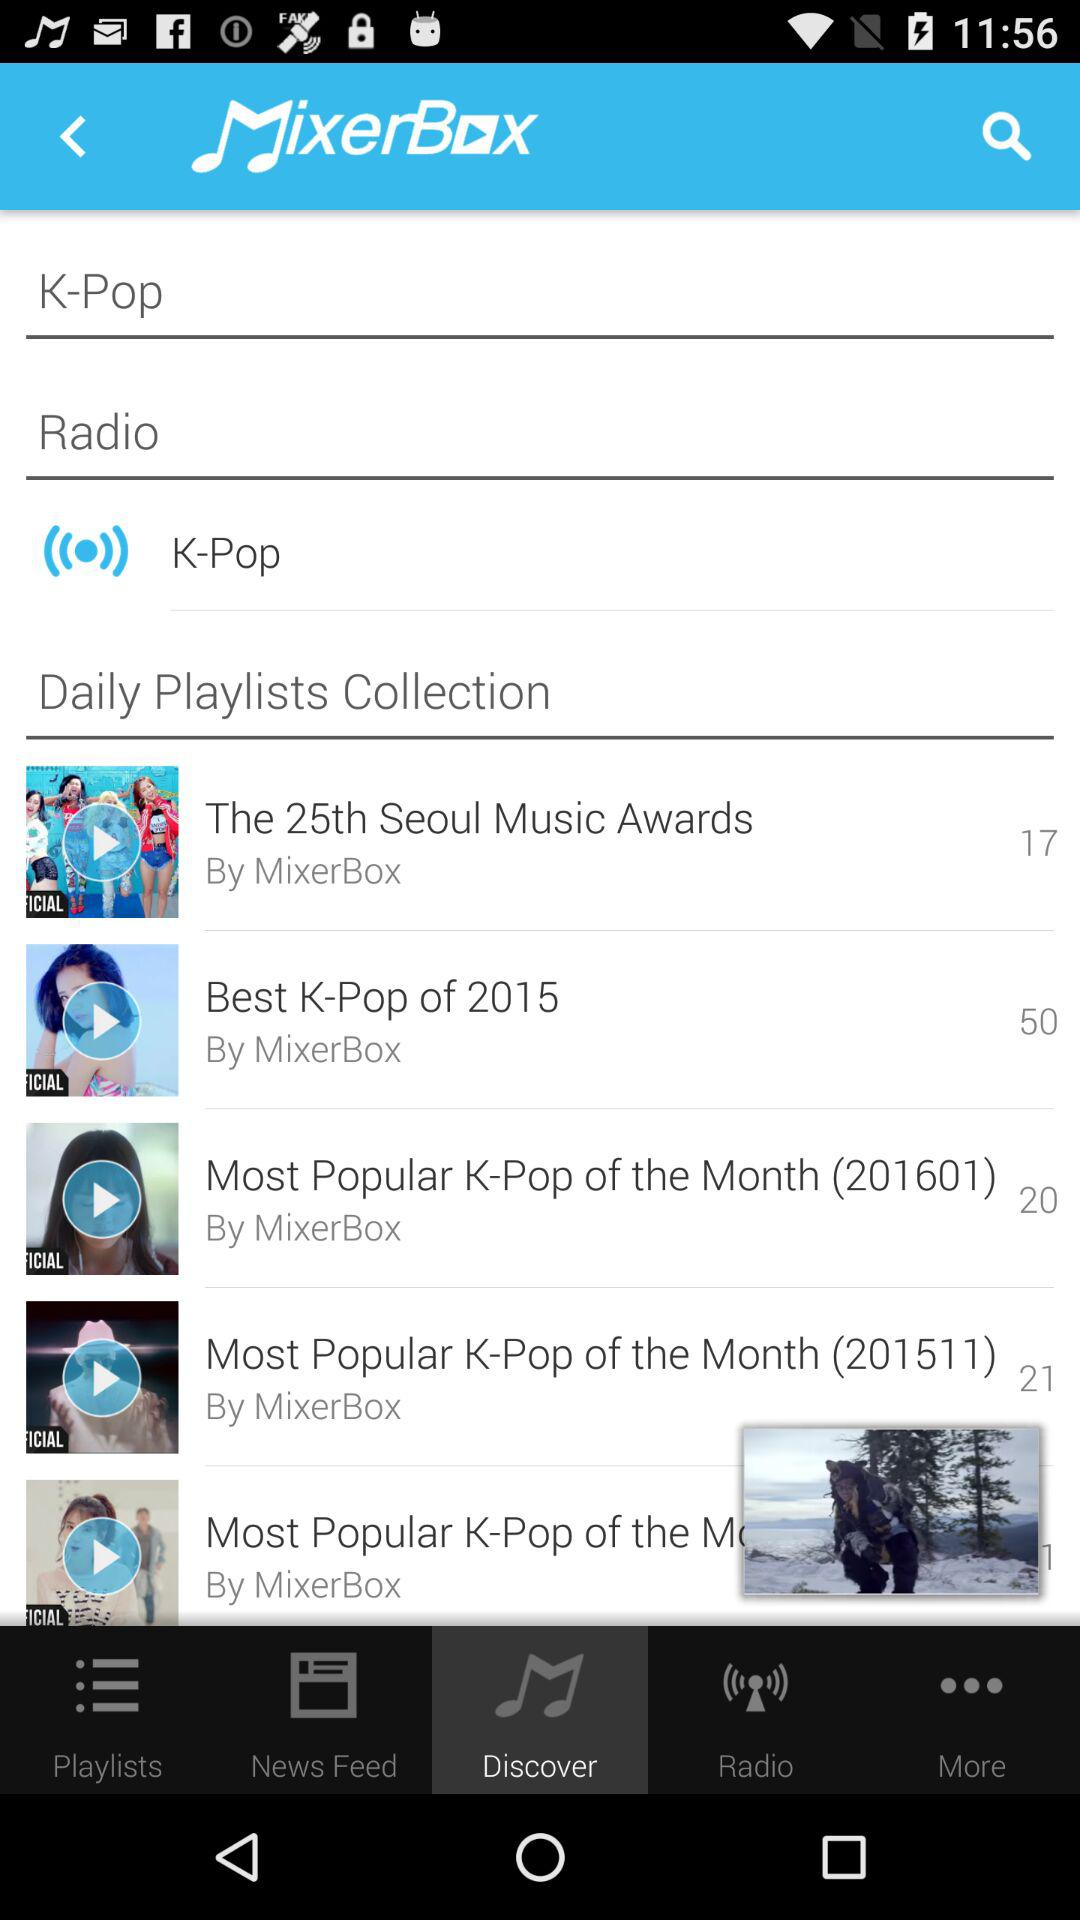What is the number of songs in "Best K-Pop of 2015"? The number of songs is 50. 